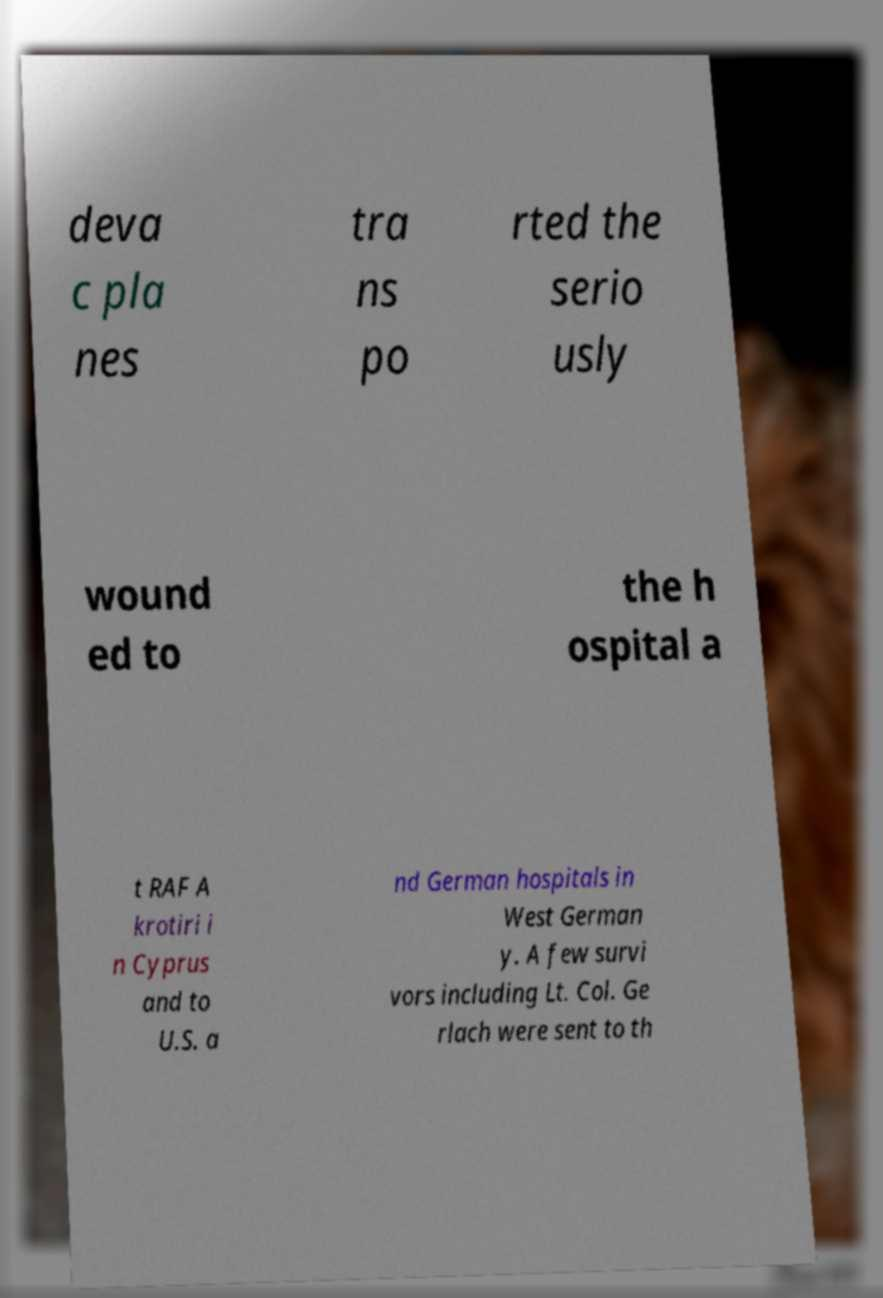I need the written content from this picture converted into text. Can you do that? deva c pla nes tra ns po rted the serio usly wound ed to the h ospital a t RAF A krotiri i n Cyprus and to U.S. a nd German hospitals in West German y. A few survi vors including Lt. Col. Ge rlach were sent to th 